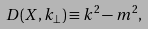<formula> <loc_0><loc_0><loc_500><loc_500>D ( X , { k } _ { \perp } ) \equiv k ^ { 2 } - m ^ { 2 } ,</formula> 